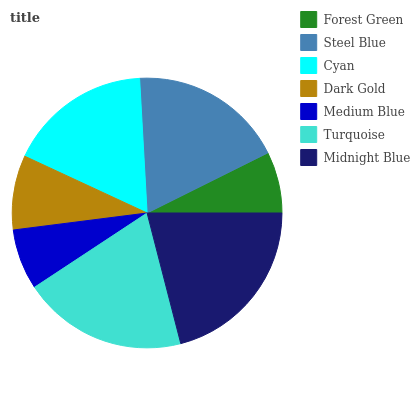Is Medium Blue the minimum?
Answer yes or no. Yes. Is Midnight Blue the maximum?
Answer yes or no. Yes. Is Steel Blue the minimum?
Answer yes or no. No. Is Steel Blue the maximum?
Answer yes or no. No. Is Steel Blue greater than Forest Green?
Answer yes or no. Yes. Is Forest Green less than Steel Blue?
Answer yes or no. Yes. Is Forest Green greater than Steel Blue?
Answer yes or no. No. Is Steel Blue less than Forest Green?
Answer yes or no. No. Is Cyan the high median?
Answer yes or no. Yes. Is Cyan the low median?
Answer yes or no. Yes. Is Medium Blue the high median?
Answer yes or no. No. Is Turquoise the low median?
Answer yes or no. No. 